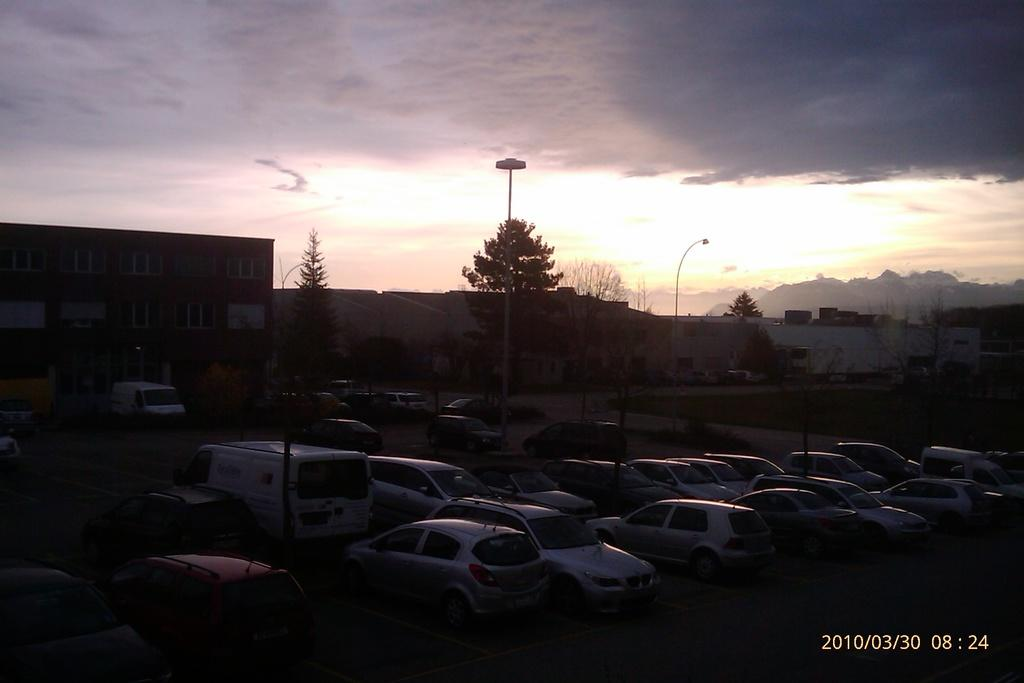What can be seen in the parking area in the image? There are many cars parked in the parking area in the image. What type of building is visible in the image? There is a house with windows in the image. What structures are present in the image besides the house? There are electric poles in the image. What is the condition of the sky in the image? The sky is visible at the top of the image, and it appears to be a sunset sky. What type of tin can be seen hanging from the electric poles in the image? There is no tin present on the electric poles in the image. How many beads are visible on the house in the image? There are no beads visible on the house in the image. 